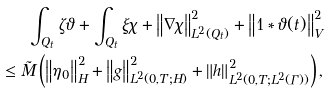<formula> <loc_0><loc_0><loc_500><loc_500>\int _ { Q _ { t } } { \zeta \vartheta } + \int _ { Q _ { t } } { \xi \chi } + \left \| \nabla \chi \right \| ^ { 2 } _ { L ^ { 2 } ( Q _ { t } ) } + \left \| 1 \ast \vartheta ( t ) \right \| ^ { 2 } _ { V } \\ \leq \tilde { M } \left ( \left \| \eta _ { 0 } \right \| ^ { 2 } _ { H } + \left \| g \right \| ^ { 2 } _ { L ^ { 2 } ( 0 , T ; H ) } + \left \| h \right \| ^ { 2 } _ { L ^ { 2 } ( 0 , T ; L ^ { 2 } ( \Gamma ) ) } \right ) ,</formula> 